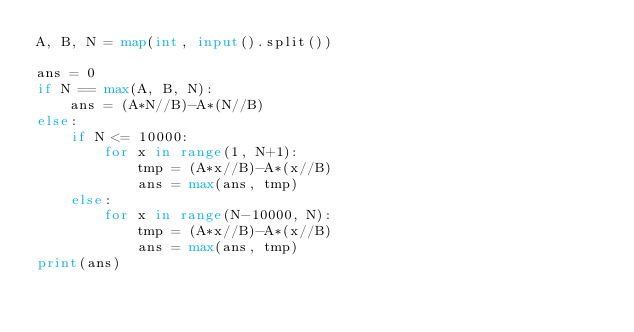Convert code to text. <code><loc_0><loc_0><loc_500><loc_500><_Python_>A, B, N = map(int, input().split())

ans = 0
if N == max(A, B, N):
    ans = (A*N//B)-A*(N//B)
else:
    if N <= 10000:
        for x in range(1, N+1):
            tmp = (A*x//B)-A*(x//B)
            ans = max(ans, tmp)
    else:
        for x in range(N-10000, N):
            tmp = (A*x//B)-A*(x//B)
            ans = max(ans, tmp)
print(ans)
</code> 